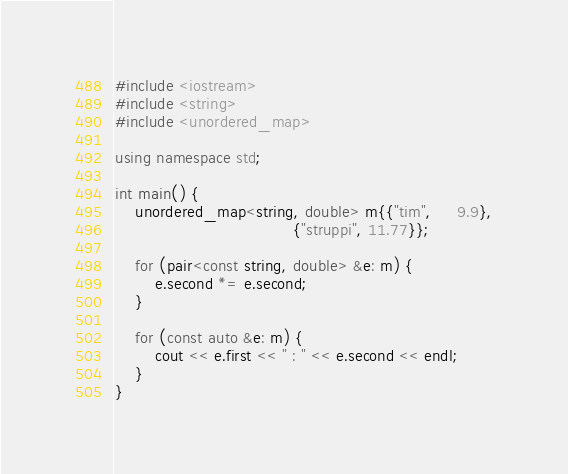Convert code to text. <code><loc_0><loc_0><loc_500><loc_500><_C++_>#include <iostream>
#include <string>
#include <unordered_map>

using namespace std;

int main() {
    unordered_map<string, double> m{{"tim",     9.9},
                                    {"struppi", 11.77}};

    for (pair<const string, double> &e: m) {
        e.second *= e.second;
    }

    for (const auto &e: m) {
        cout << e.first << " : " << e.second << endl;
    }
}</code> 